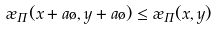<formula> <loc_0><loc_0><loc_500><loc_500>\rho _ { \Pi } ( x + a \tau , y + a \tau ) \leq \rho _ { \Pi } ( x , y )</formula> 